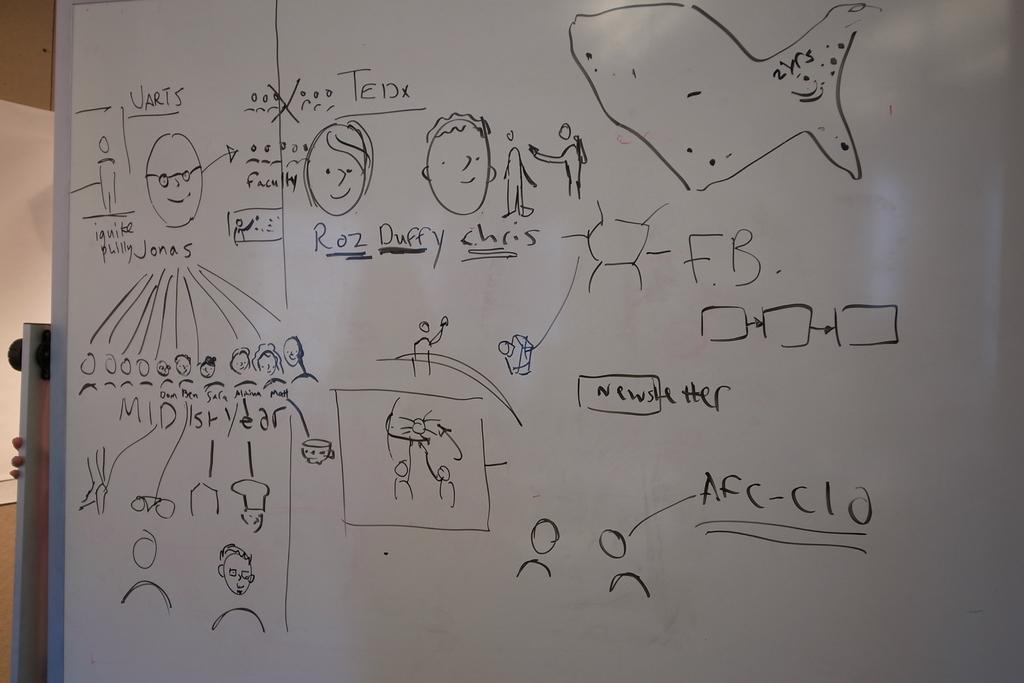<image>
Write a terse but informative summary of the picture. Drawing on a white board in black marker of Roz Duffy Chris 